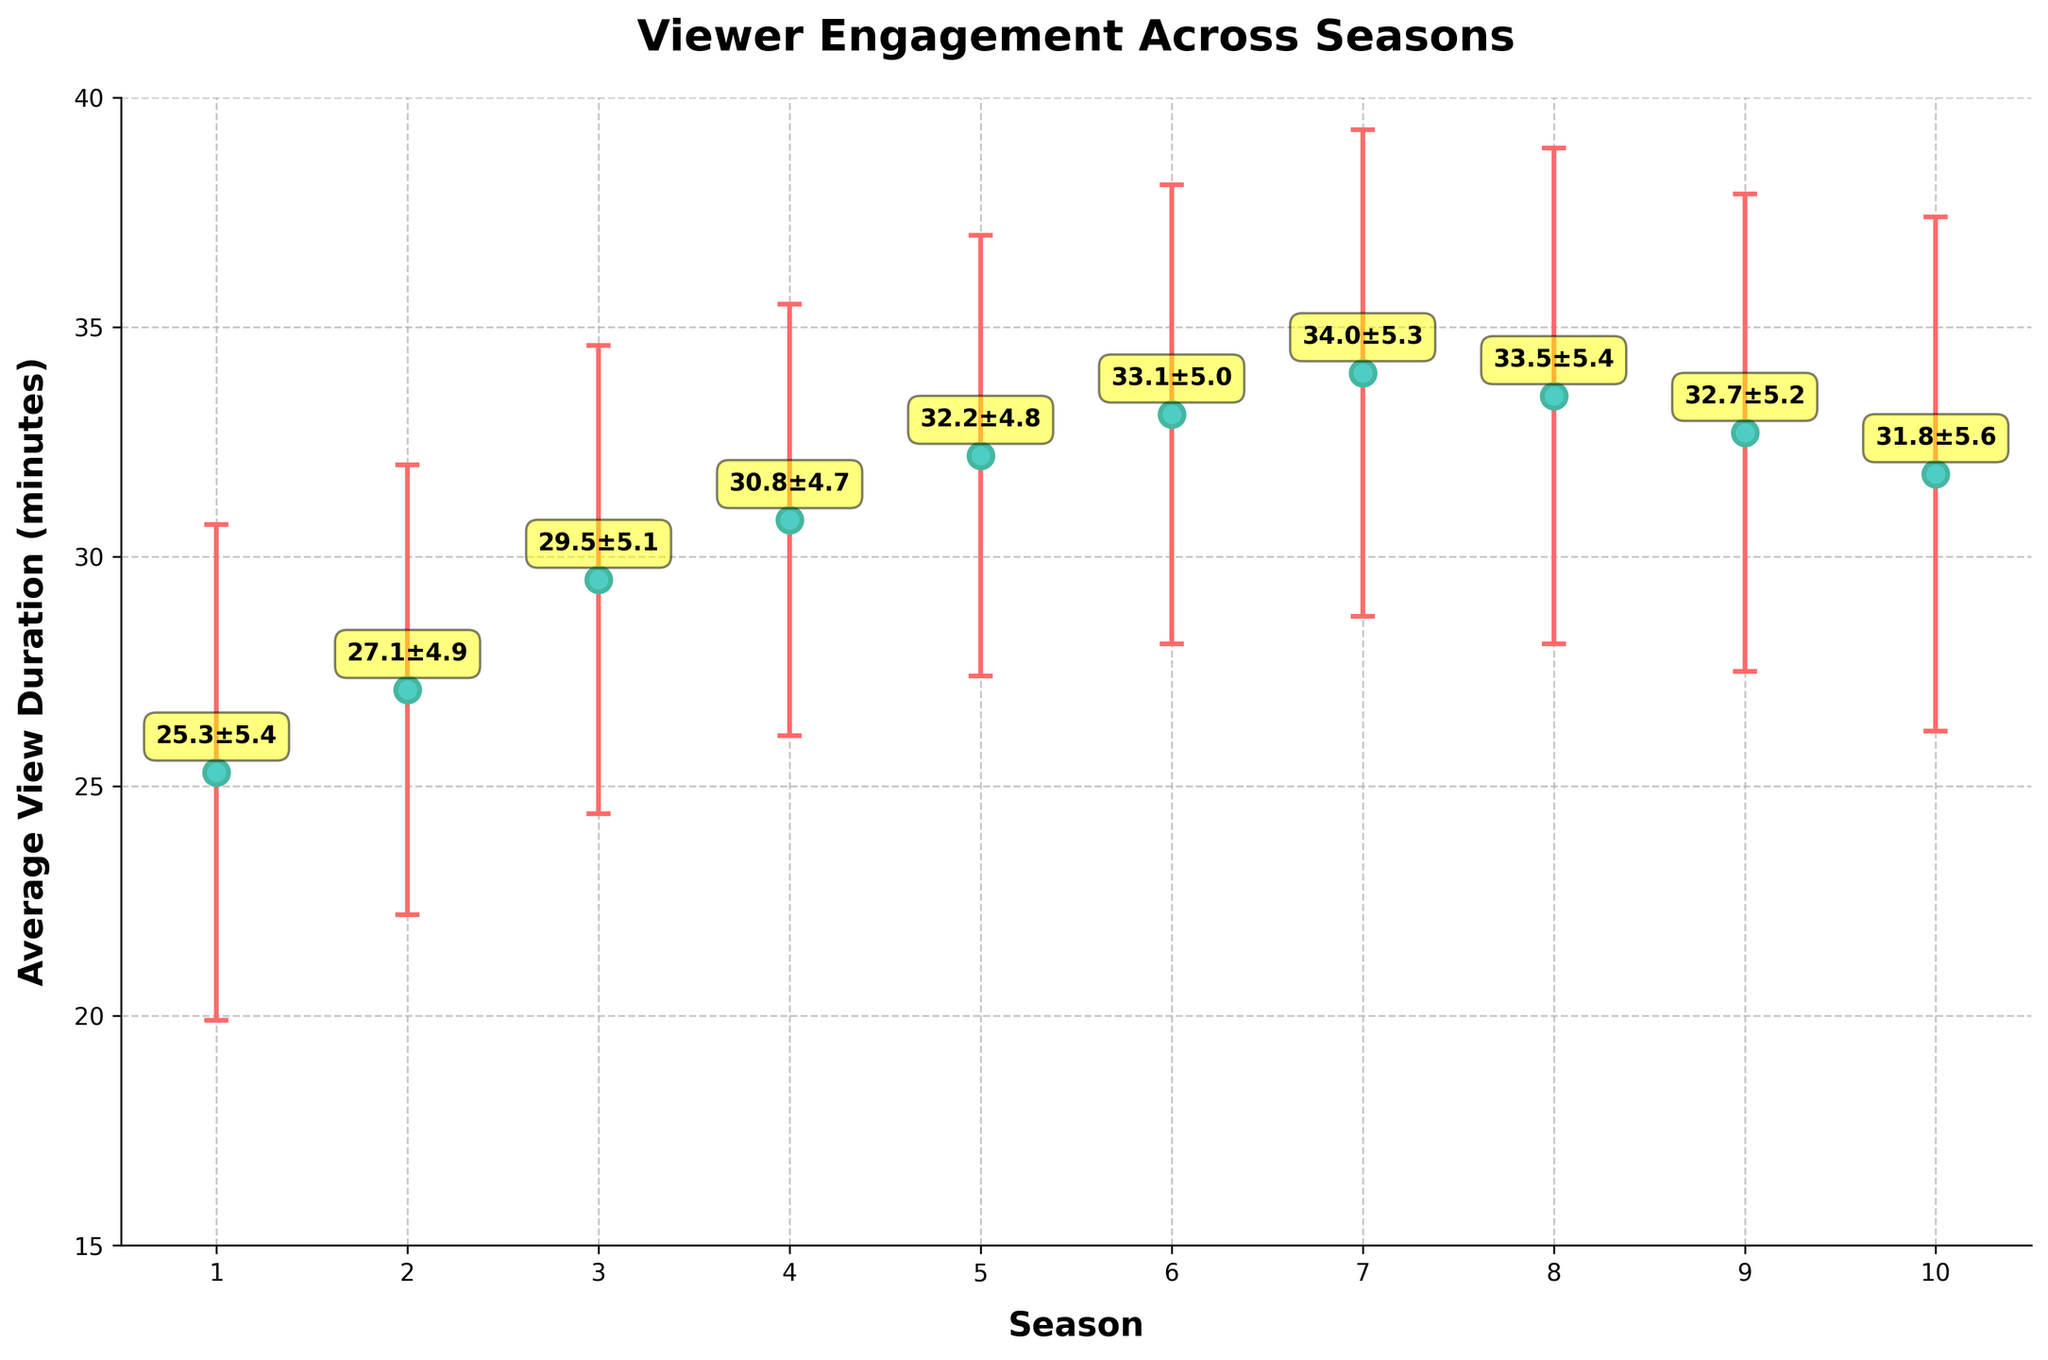What is the title of the figure? The title of the figure is prominently displayed at the top. It reads "Viewer Engagement Across Seasons".
Answer: Viewer Engagement Across Seasons What is the highest average view duration recorded, and in which season does it occur? Locate the data points on the vertical axis; the highest point appears around 34.0 minutes, occurring during Season 7.
Answer: 34.0, Season 7 Which seasons have an average view duration above 30 minutes? Scan the y-axis for data points above the 30-minute mark; these are Seasons 4, 5, 6, 7, 8, and 9.
Answer: Seasons 4, 5, 6, 7, 8, 9 What is the range of average view durations over all seasons? The range is the difference between the highest and lowest average view duration. The lowest is around 25.3 minutes (Season 1) and the highest is about 34.0 minutes (Season 7). The range is 34.0 - 25.3 = 8.7 minutes.
Answer: 8.7 minutes Which season has the lowest average view duration and what is its value? Locate the smallest data point on the vertical axis, which corresponds to 25.3 minutes and occurs in Season 1.
Answer: Season 1, 25.3 minutes How does the average view duration change from Season 3 to Season 4? Look at the data points for Seasons 3 and 4. Season 3 has about 29.5 minutes, and Season 4 has about 30.8 minutes. The change is 30.8 - 29.5 = 1.3 minutes increase.
Answer: 1.3 minutes increase Which season has the largest error bar, and what is its approximate value? Identify the season with the longest vertical line (error bar). Season 10 has the largest error bar, approximately 5.6 minutes.
Answer: Season 10, 5.6 minutes Compare the average view durations for Seasons 5 and 8. Which is higher and by how much? Look at the data points: Season 5 is approximately 32.2 minutes and Season 8 is around 33.5 minutes. The difference is 33.5 - 32.2 = 1.3 minutes in favor of Season 8.
Answer: Season 8, 1.3 minutes What is the standard deviation of the average view duration for Season 6? The error bar length corresponds to the standard deviation for Season 6, which is approximately 5.0 minutes.
Answer: 5.0 minutes What trend can be observed in average view durations from Season 1 to Season 10? Observe the general trajectory of the data points over the seasons; it shows an initial increase peaking at Season 7, followed by a slight decline towards Season 10.
Answer: Initial increase till Season 7, then slight decline 